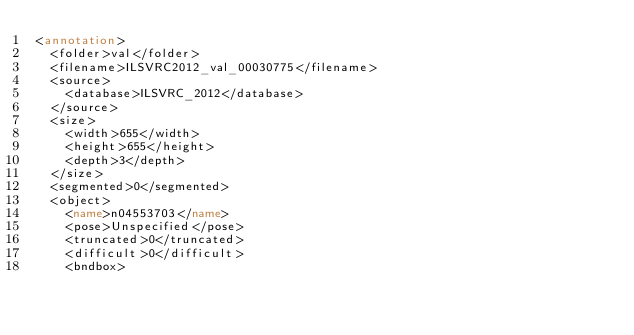<code> <loc_0><loc_0><loc_500><loc_500><_XML_><annotation>
	<folder>val</folder>
	<filename>ILSVRC2012_val_00030775</filename>
	<source>
		<database>ILSVRC_2012</database>
	</source>
	<size>
		<width>655</width>
		<height>655</height>
		<depth>3</depth>
	</size>
	<segmented>0</segmented>
	<object>
		<name>n04553703</name>
		<pose>Unspecified</pose>
		<truncated>0</truncated>
		<difficult>0</difficult>
		<bndbox></code> 